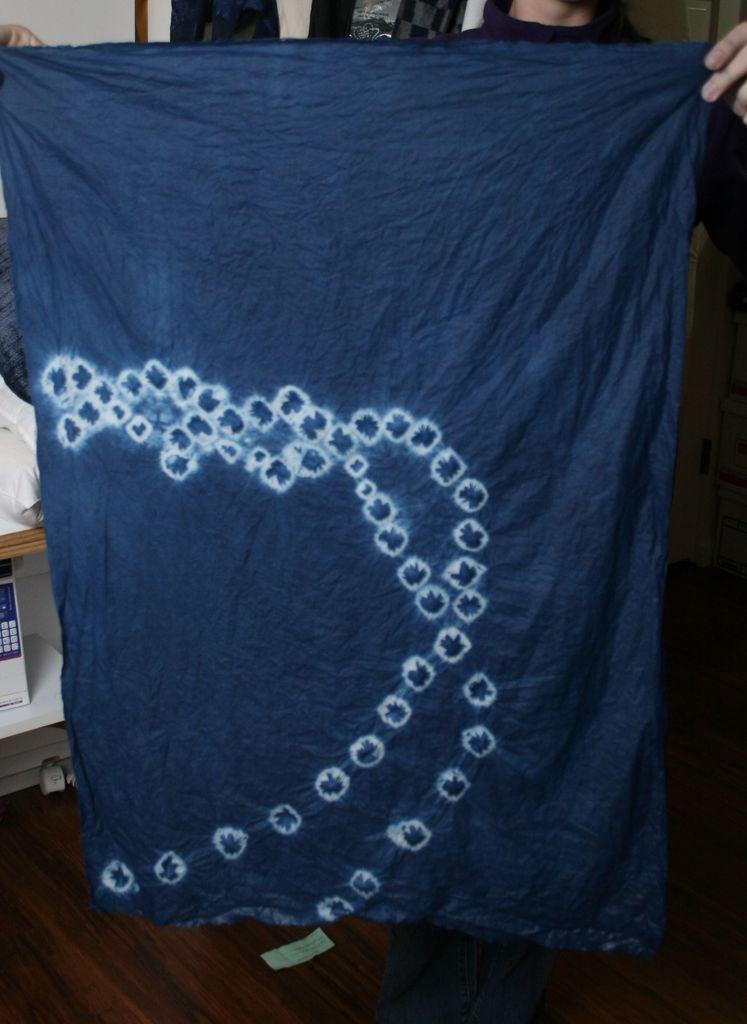Describe this image in one or two sentences. There is a person holding a violet color cloth and standing. In the background, there is white wall. 